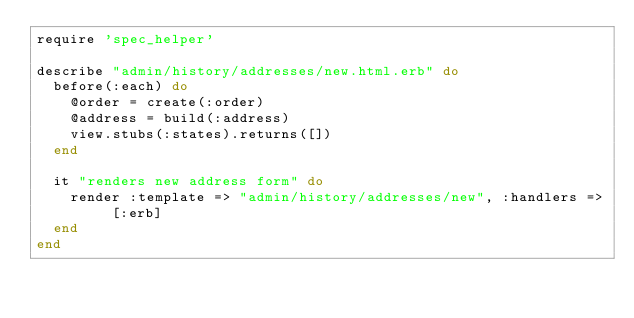Convert code to text. <code><loc_0><loc_0><loc_500><loc_500><_Ruby_>require 'spec_helper'

describe "admin/history/addresses/new.html.erb" do
  before(:each) do
    @order = create(:order)
    @address = build(:address)
    view.stubs(:states).returns([])
  end

  it "renders new address form" do
    render :template => "admin/history/addresses/new", :handlers => [:erb]
  end
end
</code> 